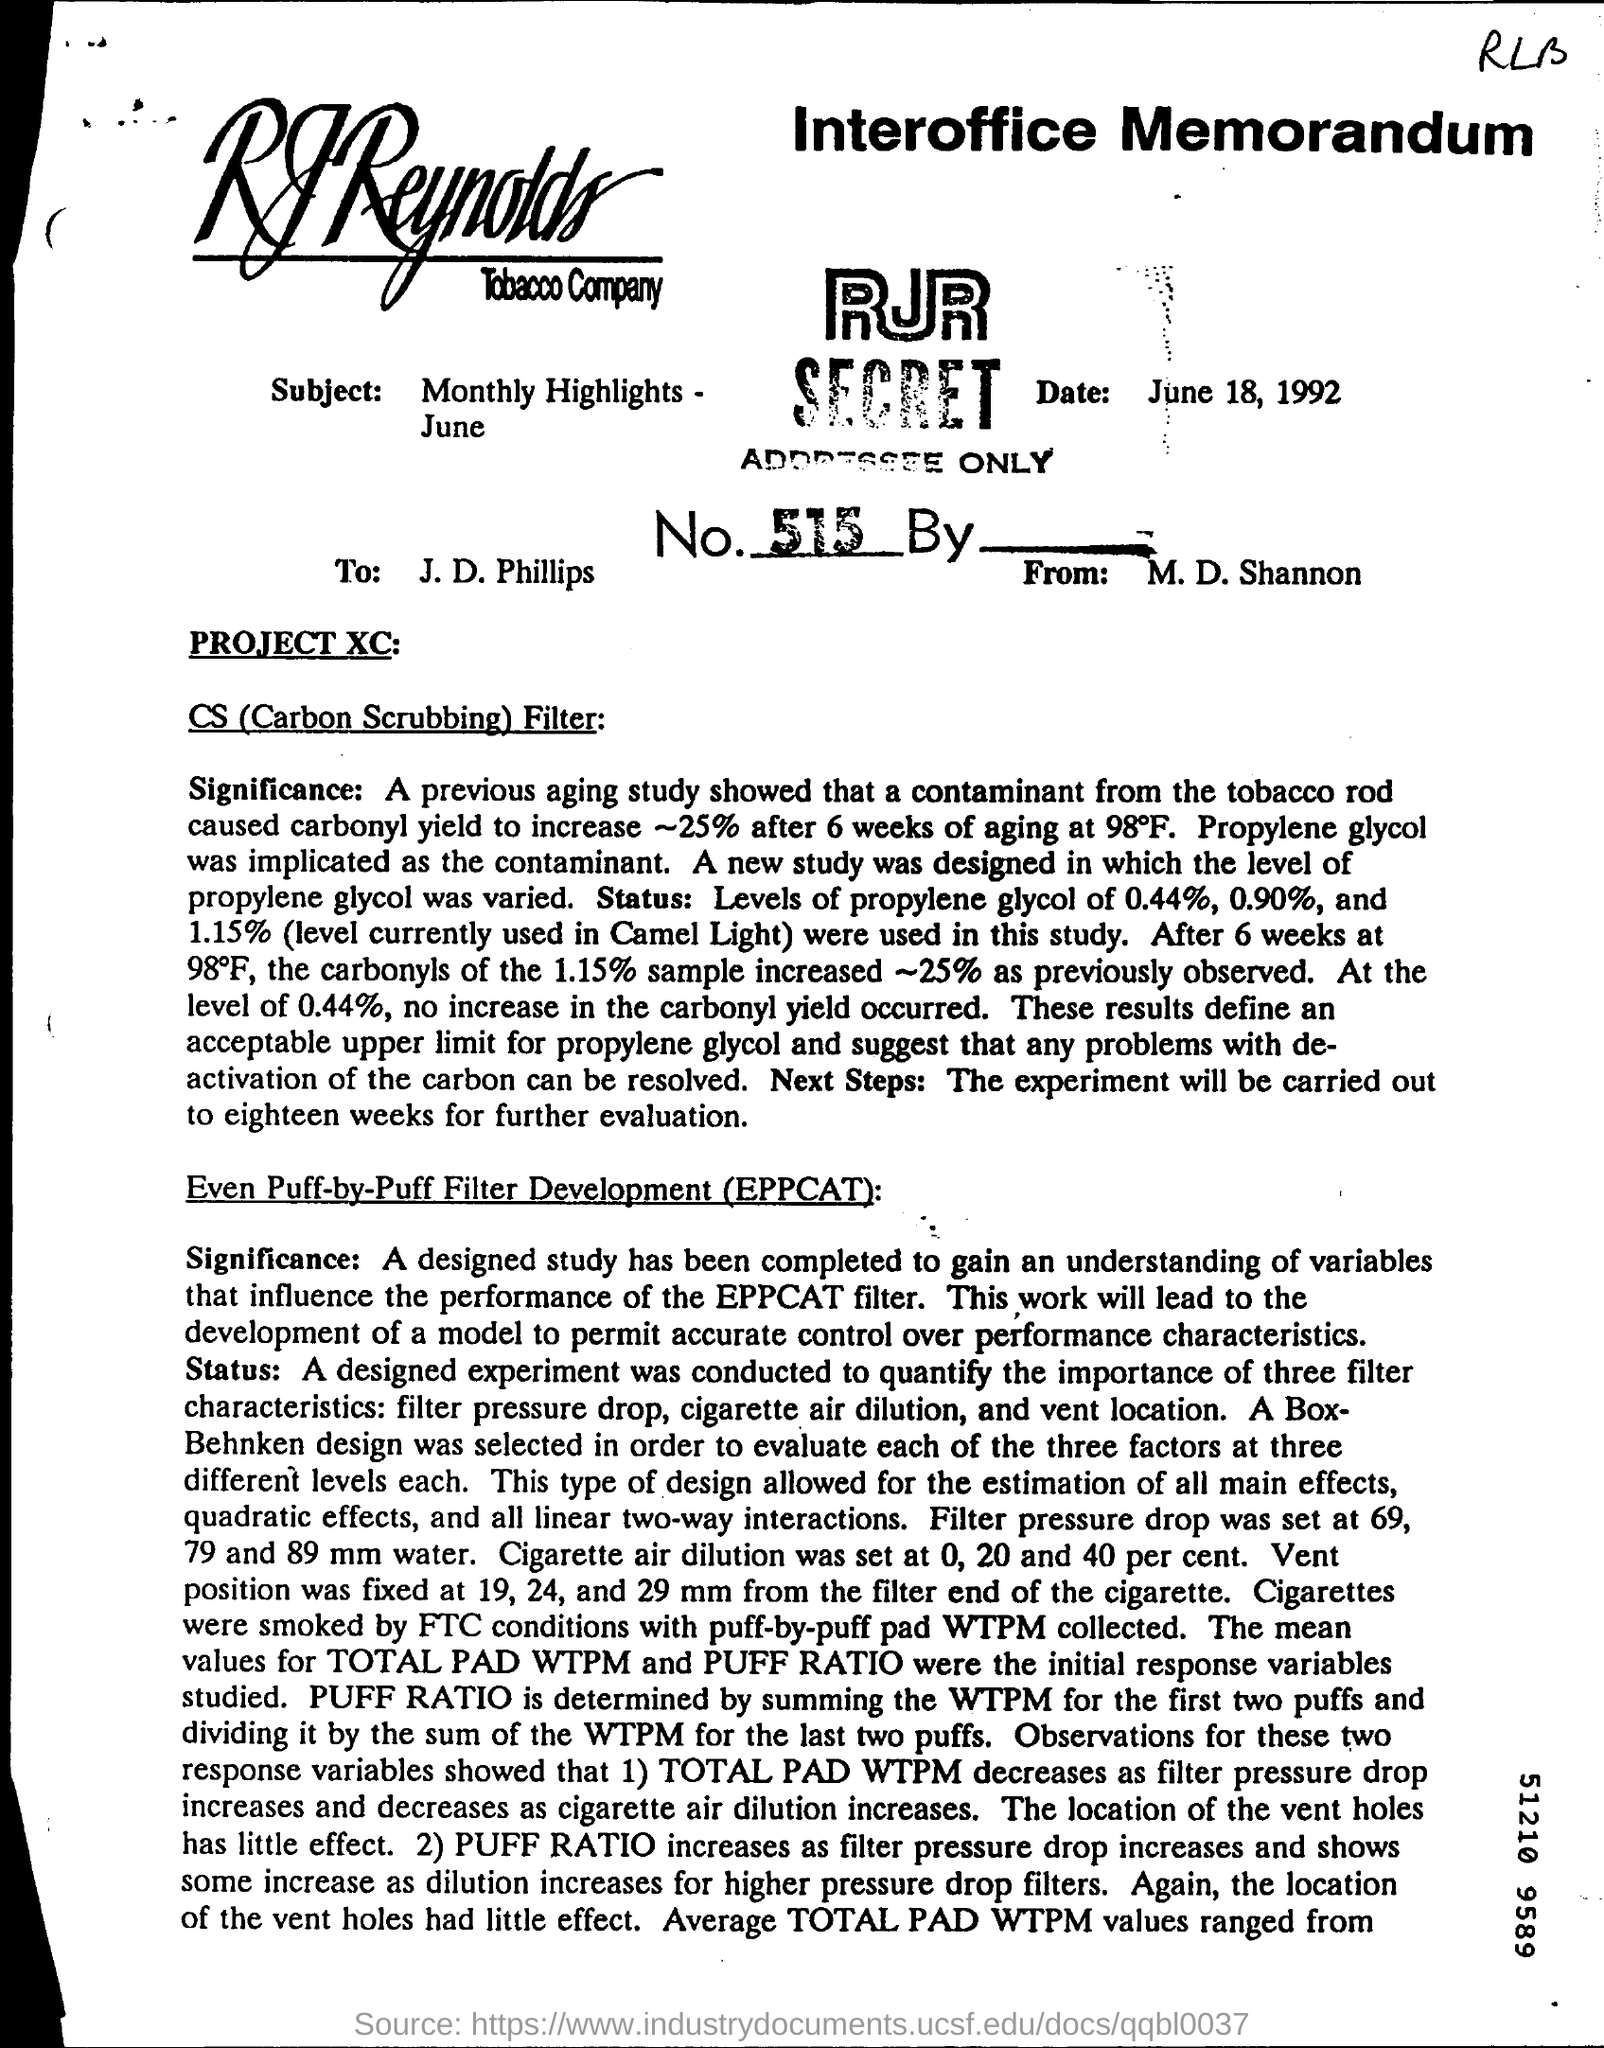List a handful of essential elements in this visual. The title of the second paragraph is "Even Puff-by-Puff Filter Development (EPPCAT)? The name of the tobacco company is R.J. Reynolds Tobacco Company. This interoffice memorandum is addressed to J. D. Phillips. The date mentioned is June 18, 1992. 